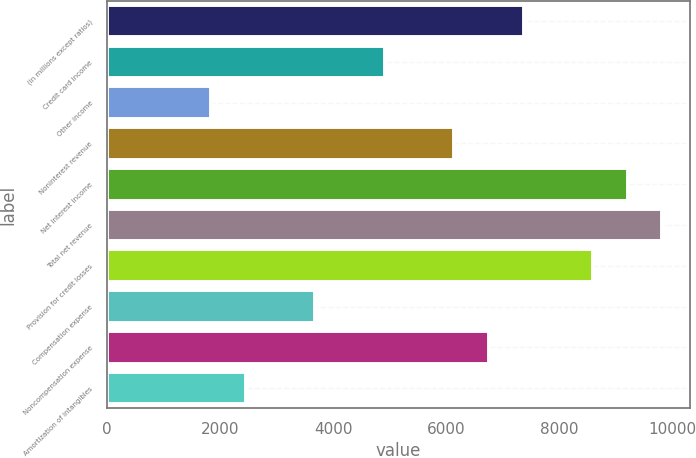Convert chart. <chart><loc_0><loc_0><loc_500><loc_500><bar_chart><fcel>(in millions except ratios)<fcel>Credit card income<fcel>Other income<fcel>Noninterest revenue<fcel>Net interest income<fcel>Total net revenue<fcel>Provision for credit losses<fcel>Compensation expense<fcel>Noncompensation expense<fcel>Amortization of intangibles<nl><fcel>7372.6<fcel>4915.4<fcel>1843.9<fcel>6144<fcel>9215.5<fcel>9829.8<fcel>8601.2<fcel>3686.8<fcel>6758.3<fcel>2458.2<nl></chart> 